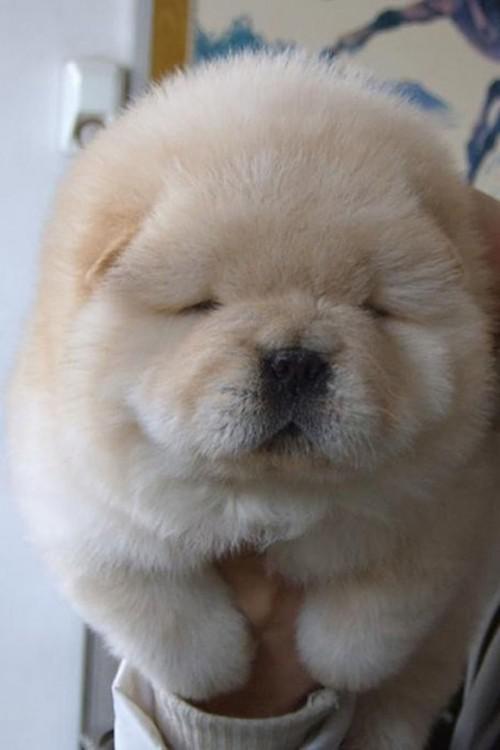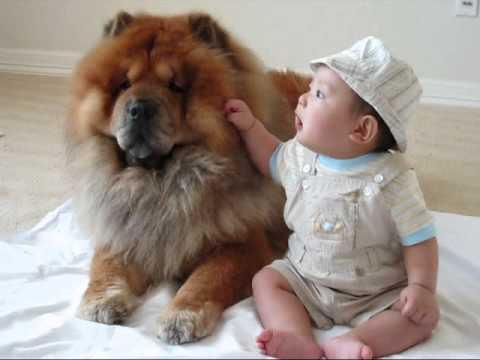The first image is the image on the left, the second image is the image on the right. For the images displayed, is the sentence "The right image shows a baby sitting to the right of an adult chow, and the left image shows one forward-turned cream-colored chow puppy." factually correct? Answer yes or no. Yes. The first image is the image on the left, the second image is the image on the right. For the images shown, is this caption "The left and right image contains the same number of dog and on the right image there is a child." true? Answer yes or no. Yes. 